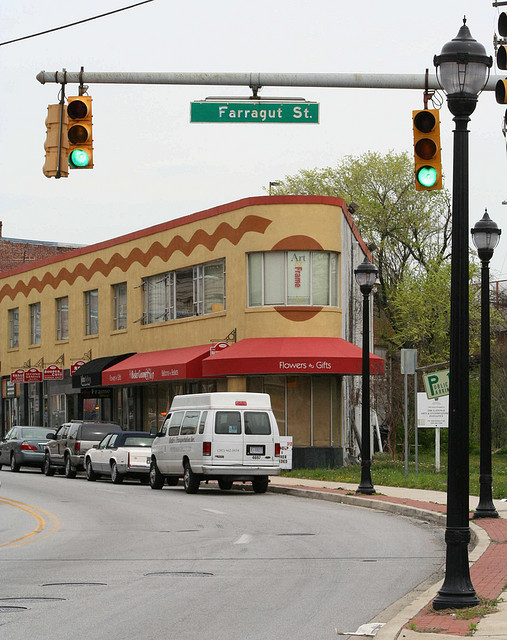Please extract the text content from this image. Framo Girls Flowers P St. Farragut 